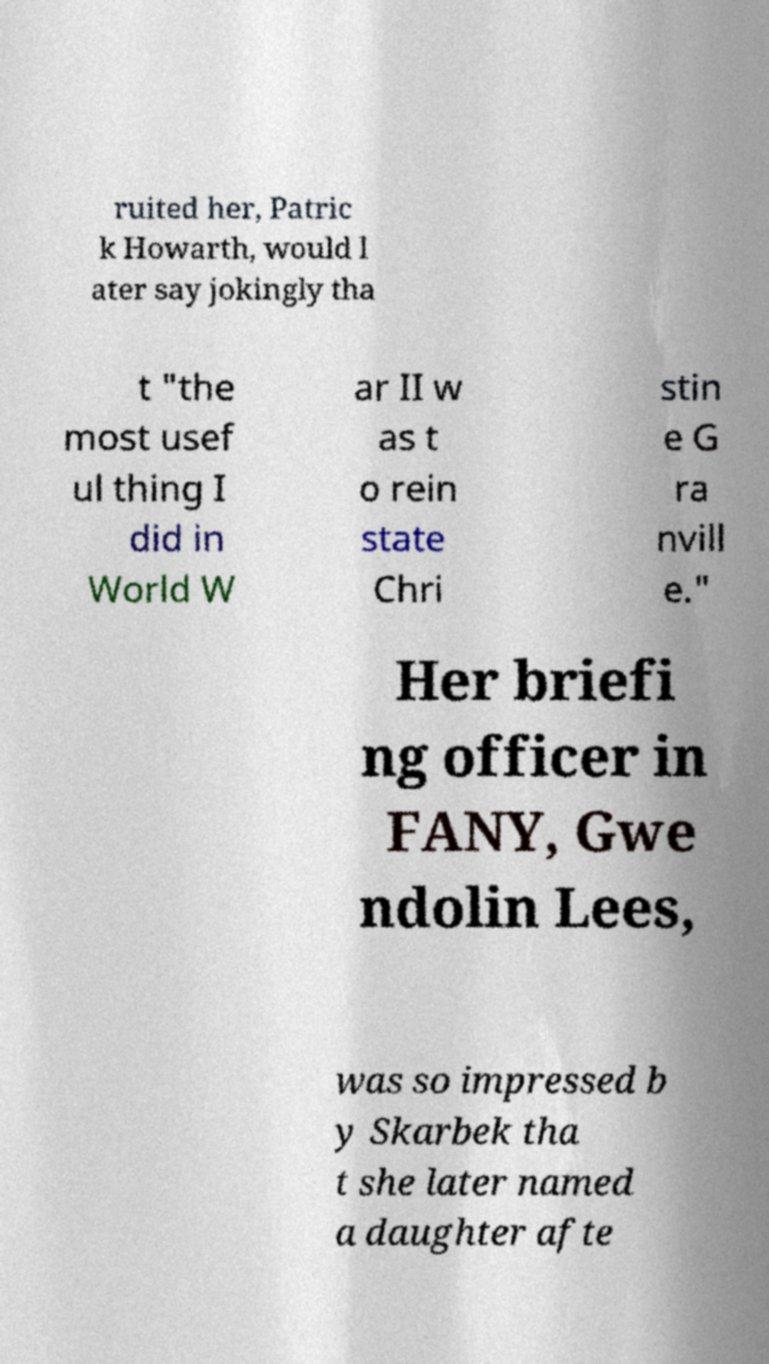For documentation purposes, I need the text within this image transcribed. Could you provide that? ruited her, Patric k Howarth, would l ater say jokingly tha t "the most usef ul thing I did in World W ar II w as t o rein state Chri stin e G ra nvill e." Her briefi ng officer in FANY, Gwe ndolin Lees, was so impressed b y Skarbek tha t she later named a daughter afte 